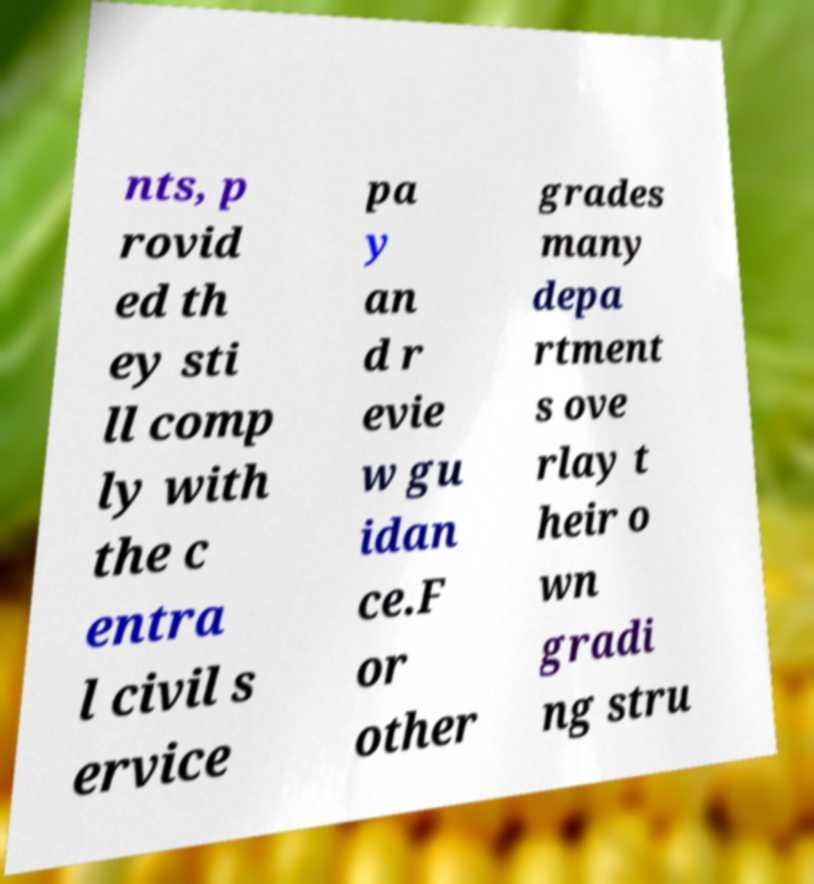There's text embedded in this image that I need extracted. Can you transcribe it verbatim? nts, p rovid ed th ey sti ll comp ly with the c entra l civil s ervice pa y an d r evie w gu idan ce.F or other grades many depa rtment s ove rlay t heir o wn gradi ng stru 